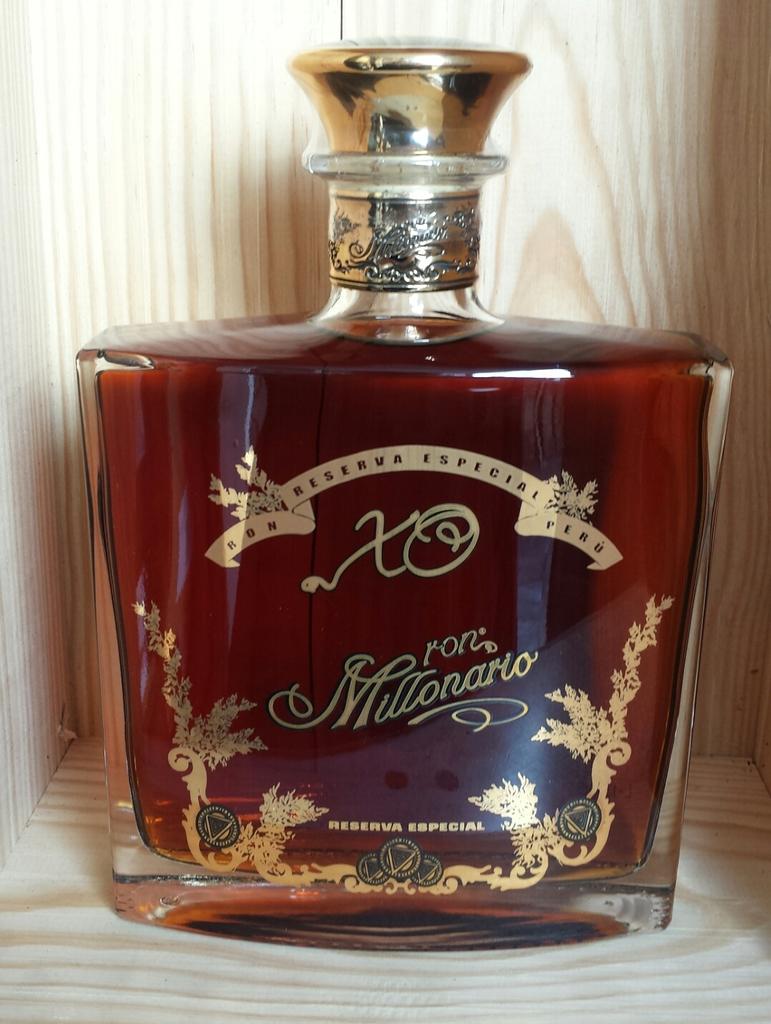What is the brand of this container?
Ensure brevity in your answer.  Millonario. Is this written in english?
Your response must be concise. No. 